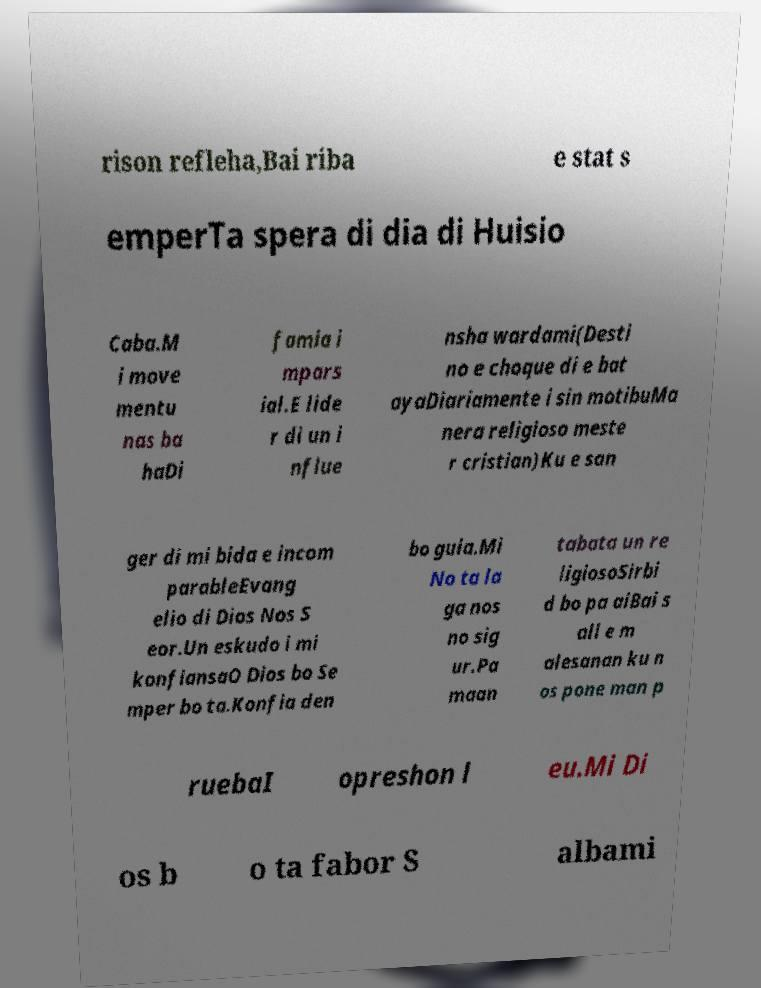Can you read and provide the text displayed in the image?This photo seems to have some interesting text. Can you extract and type it out for me? rison refleha,Bai riba e stat s emperTa spera di dia di Huisio Caba.M i move mentu nas ba haDi famia i mpars ial.E lide r di un i nflue nsha wardami(Desti no e choque di e bat ayaDiariamente i sin motibuMa nera religioso meste r cristian)Ku e san ger di mi bida e incom parableEvang elio di Dios Nos S eor.Un eskudo i mi konfiansaO Dios bo Se mper bo ta.Konfia den bo guia.Mi No ta la ga nos no sig ur.Pa maan tabata un re ligiosoSirbi d bo pa aiBai s ali e m alesanan ku n os pone man p ruebaI opreshon l eu.Mi Di os b o ta fabor S albami 